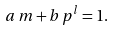Convert formula to latex. <formula><loc_0><loc_0><loc_500><loc_500>a \, m + b \, p ^ { l } = 1 .</formula> 